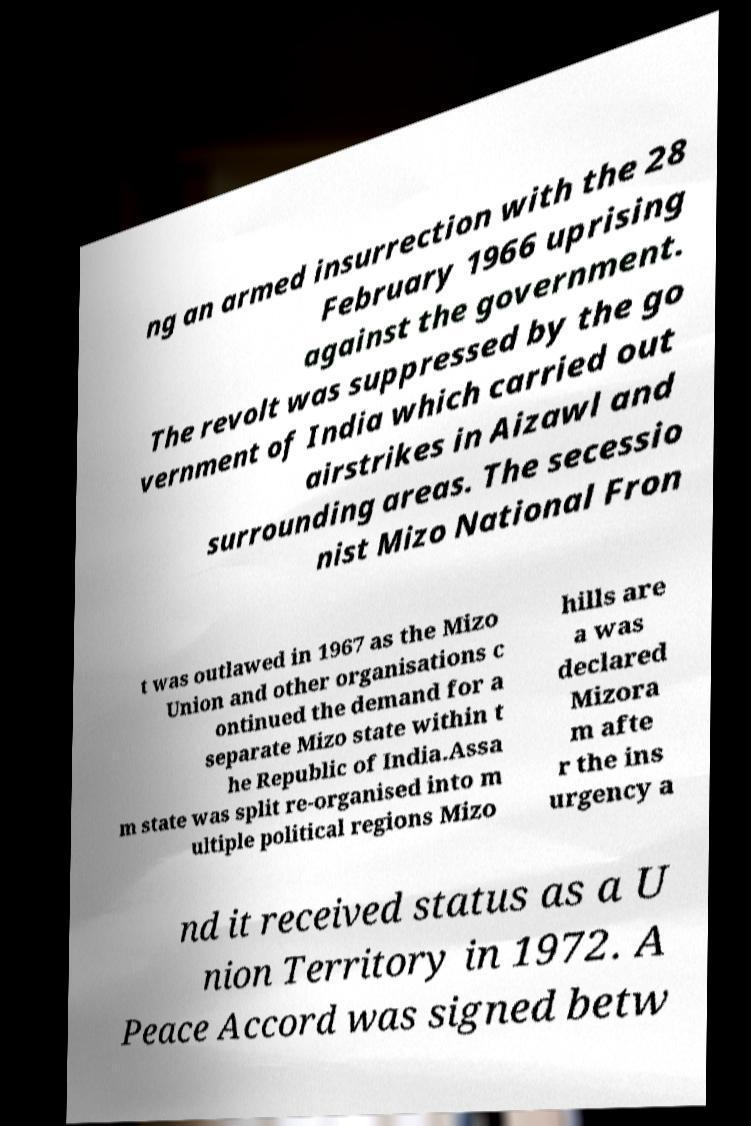I need the written content from this picture converted into text. Can you do that? ng an armed insurrection with the 28 February 1966 uprising against the government. The revolt was suppressed by the go vernment of India which carried out airstrikes in Aizawl and surrounding areas. The secessio nist Mizo National Fron t was outlawed in 1967 as the Mizo Union and other organisations c ontinued the demand for a separate Mizo state within t he Republic of India.Assa m state was split re-organised into m ultiple political regions Mizo hills are a was declared Mizora m afte r the ins urgency a nd it received status as a U nion Territory in 1972. A Peace Accord was signed betw 